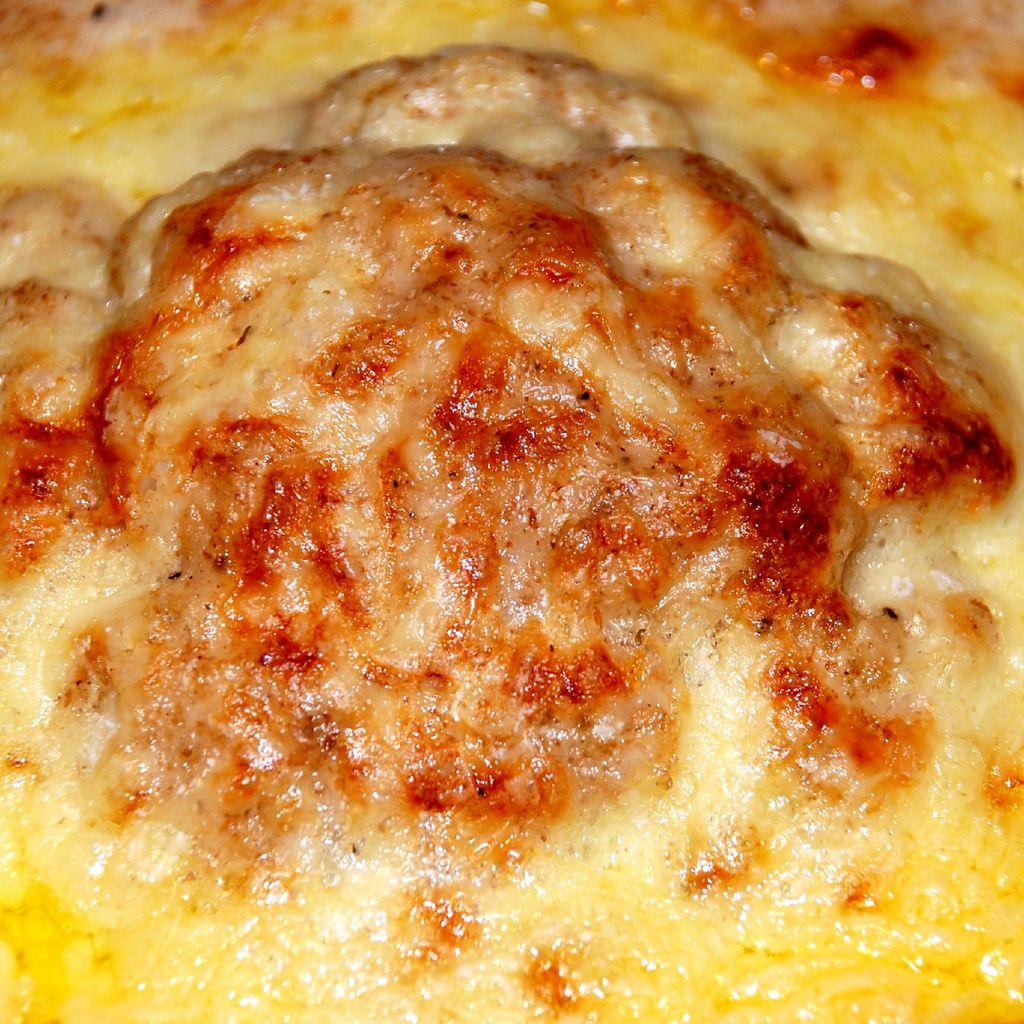What colors can be seen in the food depicted in the image? The food in the image has yellow, cream, and red colors. How many ducks are sitting on the eye in the image? There are no ducks or eyes present in the image; it only features food with different colors. 